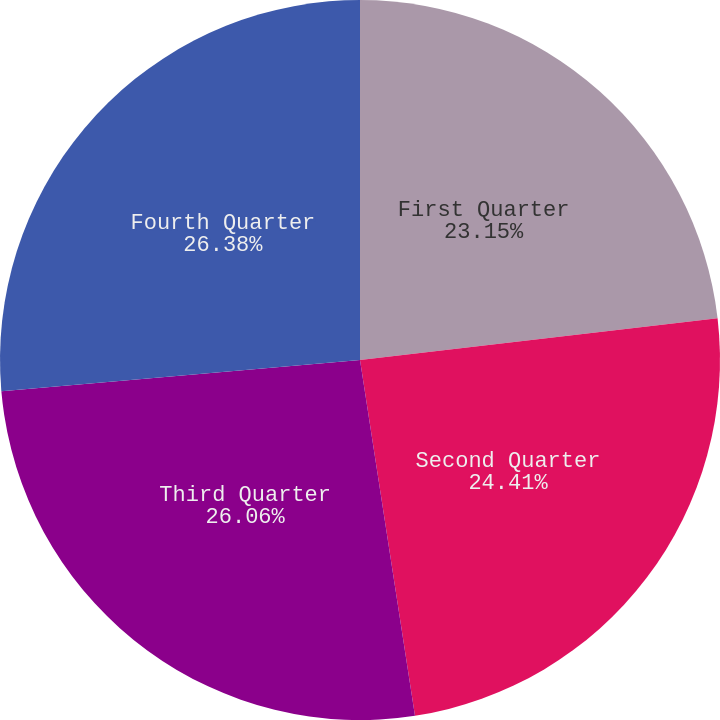Convert chart. <chart><loc_0><loc_0><loc_500><loc_500><pie_chart><fcel>First Quarter<fcel>Second Quarter<fcel>Third Quarter<fcel>Fourth Quarter<nl><fcel>23.15%<fcel>24.41%<fcel>26.06%<fcel>26.38%<nl></chart> 